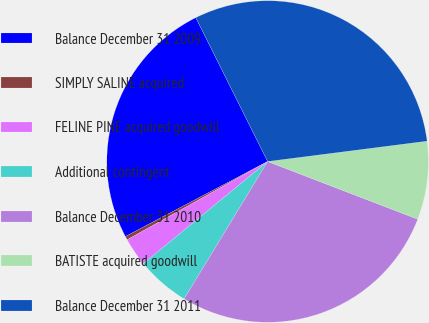Convert chart. <chart><loc_0><loc_0><loc_500><loc_500><pie_chart><fcel>Balance December 31 2009<fcel>SIMPLY SALINE acquired<fcel>FELINE PINE acquired goodwill<fcel>Additional contingent<fcel>Balance December 31 2010<fcel>BATISTE acquired goodwill<fcel>Balance December 31 2011<nl><fcel>25.35%<fcel>0.36%<fcel>2.86%<fcel>5.36%<fcel>27.85%<fcel>7.86%<fcel>30.35%<nl></chart> 